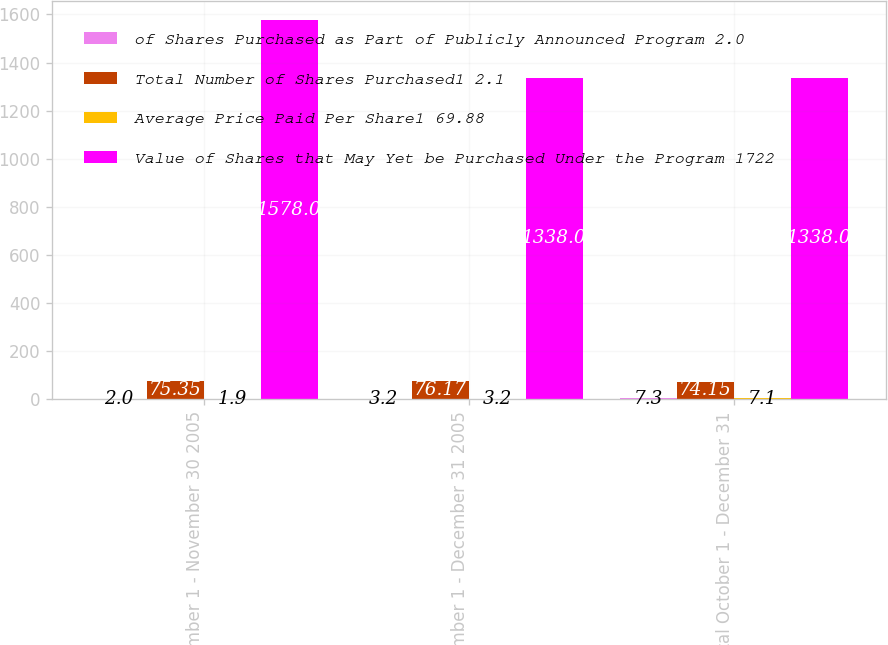Convert chart. <chart><loc_0><loc_0><loc_500><loc_500><stacked_bar_chart><ecel><fcel>November 1 - November 30 2005<fcel>December 1 - December 31 2005<fcel>Total October 1 - December 31<nl><fcel>of Shares Purchased as Part of Publicly Announced Program 2.0<fcel>2<fcel>3.2<fcel>7.3<nl><fcel>Total Number of Shares Purchased1 2.1<fcel>75.35<fcel>76.17<fcel>74.15<nl><fcel>Average Price Paid Per Share1 69.88<fcel>1.9<fcel>3.2<fcel>7.1<nl><fcel>Value of Shares that May Yet be Purchased Under the Program 1722<fcel>1578<fcel>1338<fcel>1338<nl></chart> 